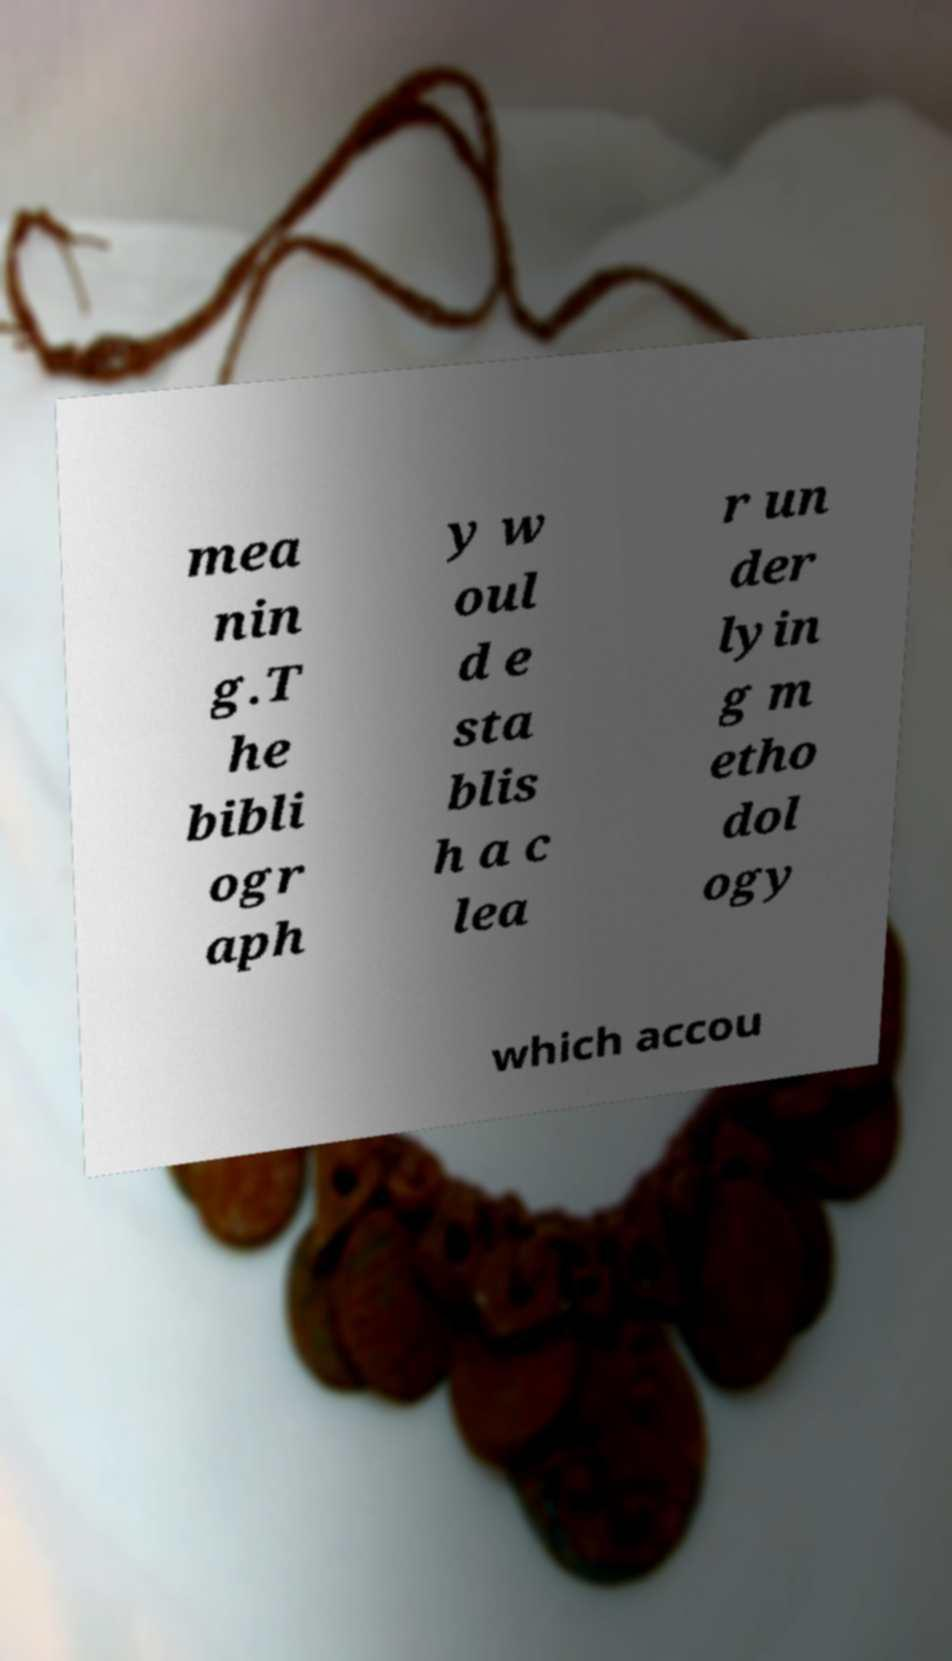For documentation purposes, I need the text within this image transcribed. Could you provide that? mea nin g.T he bibli ogr aph y w oul d e sta blis h a c lea r un der lyin g m etho dol ogy which accou 